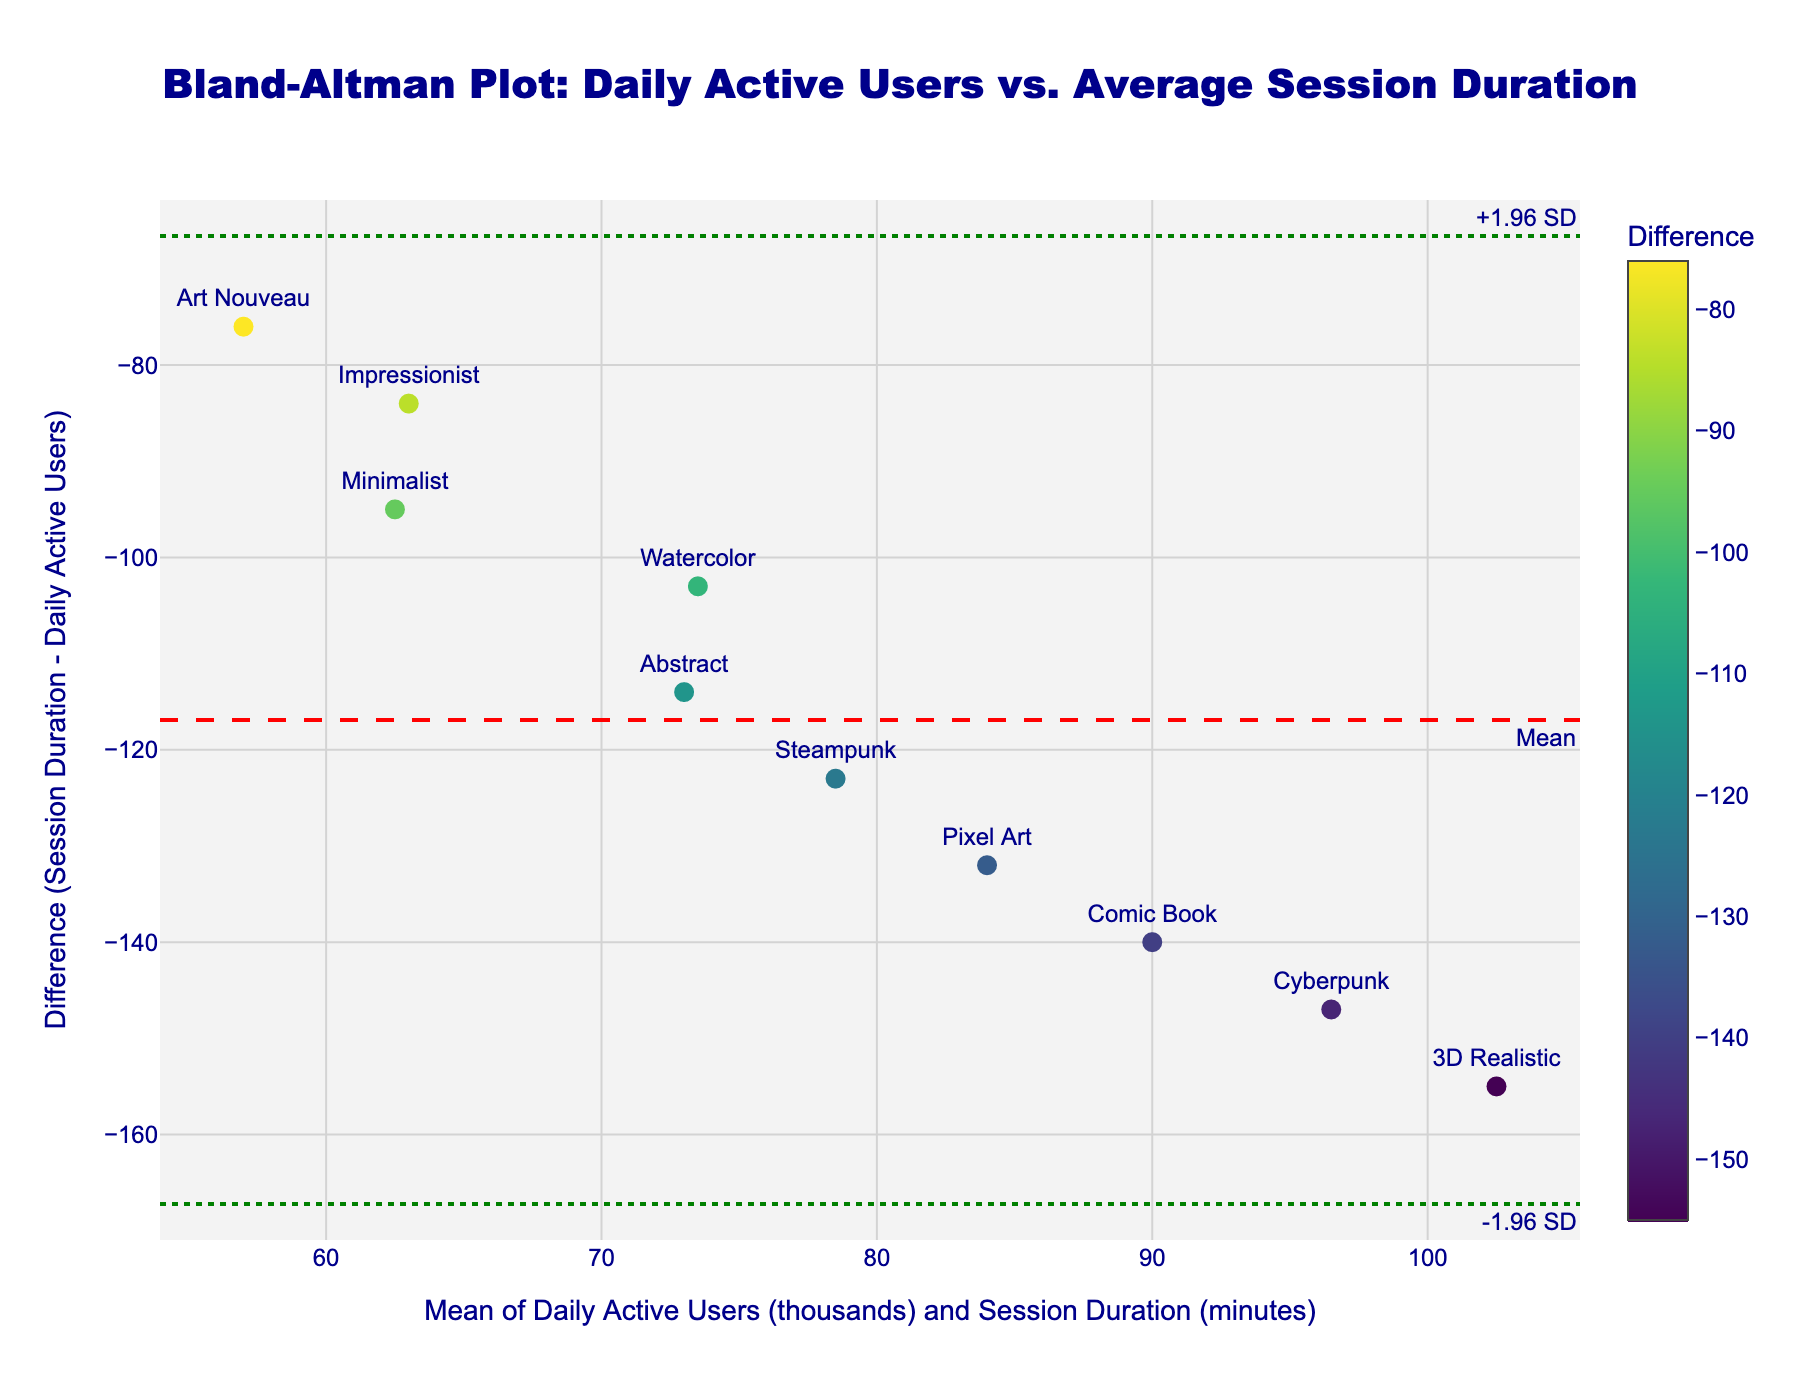What's the title of this plot? The title is often located at the top of the plot and provides a summary of what the plot is showing.
Answer: Bland-Altman Plot: Daily Active Users vs. Average Session Duration What does the x-axis represent? The x-axis represents the mean of daily active users (in thousands) and average session duration (in minutes). This information is typically detailed in the axis label.
Answer: Mean of Daily Active Users (thousands) and Session Duration (minutes) Which artistic style has the largest positive difference? To identify this, locate the data point furthest above the x-axis (positive y-value) and check the label associated with it.
Answer: 3D Realistic What is the mean difference value in this plot? The mean difference value is usually represented by a dashed horizontal line, often annotated. Look for a line labeled "Mean."
Answer: Near 5.39 What does the color of the markers represent? The color typically denotes another variable of interest. According to the plot, the color represents the difference, often highlighted using a color scale bar.
Answer: Difference What artistic styles fall within the ±1.96 SD lines? Identify the data points situated between the two dotted horizontal lines labeled "+1.96 SD" and "-1.96 SD." Then check their labels.
Answer: Most styles except 3D Realistic and possibly minimal deviations How does the mean difference for 'Pixel Art' compare with the mean difference for 'Watercolor'? To compare, find both points on the y-axis: 'Pixel Art' should be very close to the x-axis if it has a small difference, whereas 'Watercolor' will have a larger one. 'Watercolor' should be higher if the difference is positive.
Answer: Watercolor has a larger difference than Pixel Art What is the spread of the differences measured by the ±1.96 SD lines? The lines are typically labeled and measure the standard deviation multiplicatively. First, find the difference between the standard deviation (top and bottom).
Answer: Approximately 13.918 Which artistic styles have negative differences? Negative differences are below the x-axis (negative y-values). Identify these points and check their labels.
Answer: Pixel Art, Minimalist, and Steampunk Are there more data points with positive or negative differences? Count how many points are above and below the x-axis (positive and negative sides) respectively.
Answer: More positive differences 